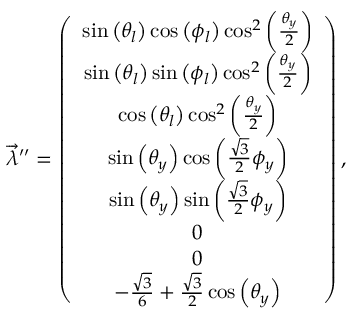<formula> <loc_0><loc_0><loc_500><loc_500>\begin{array} { r } { \overrightarrow { \lambda } ^ { \prime \prime } = \left ( \begin{array} { c } { \sin \left ( \theta _ { l } \right ) \cos \left ( \phi _ { l } \right ) \cos ^ { 2 } \left ( \frac { \theta _ { y } } { 2 } \right ) } \\ { \sin \left ( \theta _ { l } \right ) \sin \left ( \phi _ { l } \right ) \cos ^ { 2 } \left ( \frac { \theta _ { y } } { 2 } \right ) } \\ { \cos \left ( \theta _ { l } \right ) \cos ^ { 2 } \left ( \frac { \theta _ { y } } { 2 } \right ) } \\ { \sin \left ( \theta _ { y } \right ) \cos \left ( \frac { \sqrt { 3 } } { 2 } \phi _ { y } \right ) } \\ { \sin \left ( \theta _ { y } \right ) \sin \left ( \frac { \sqrt { 3 } } { 2 } \phi _ { y } \right ) } \\ { 0 } \\ { 0 } \\ { - \frac { \sqrt { 3 } } { 6 } + \frac { \sqrt { 3 } } { 2 } \cos \left ( \theta _ { y } \right ) } \end{array} \right ) , } \end{array}</formula> 